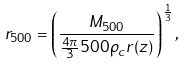<formula> <loc_0><loc_0><loc_500><loc_500>r _ { 5 0 0 } = \left ( \frac { M _ { 5 0 0 } } { \frac { 4 \pi } { 3 } 5 0 0 \rho _ { c } r ( z ) } \right ) ^ { \frac { 1 } { 3 } } ,</formula> 